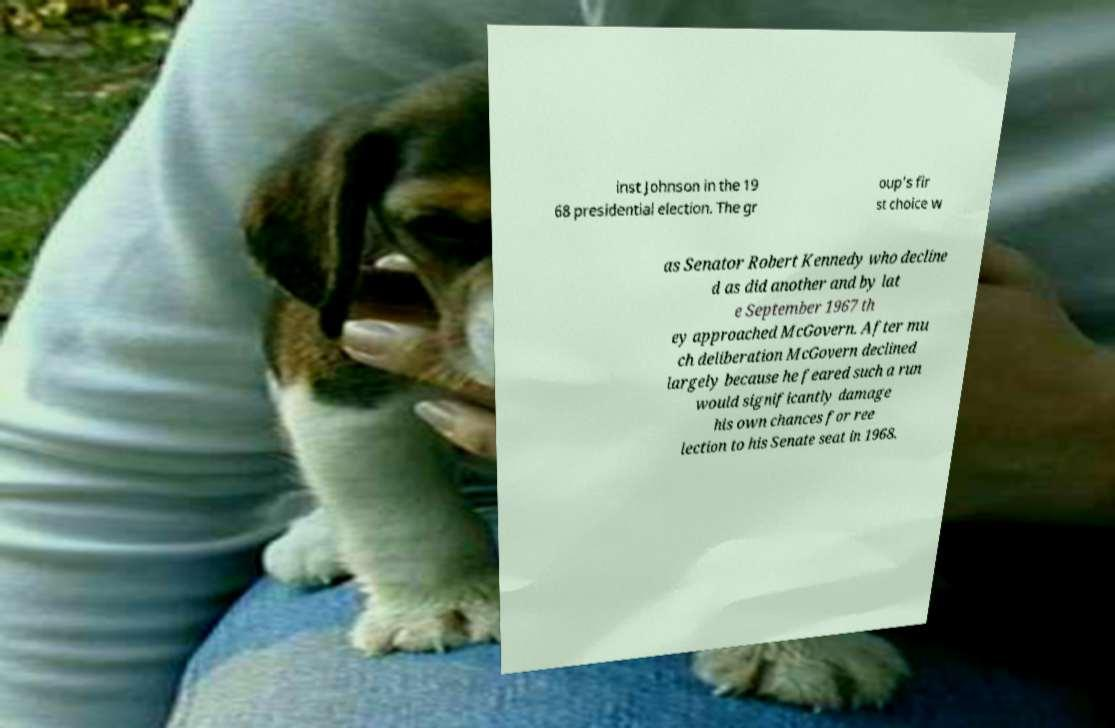Could you extract and type out the text from this image? inst Johnson in the 19 68 presidential election. The gr oup's fir st choice w as Senator Robert Kennedy who decline d as did another and by lat e September 1967 th ey approached McGovern. After mu ch deliberation McGovern declined largely because he feared such a run would significantly damage his own chances for ree lection to his Senate seat in 1968. 